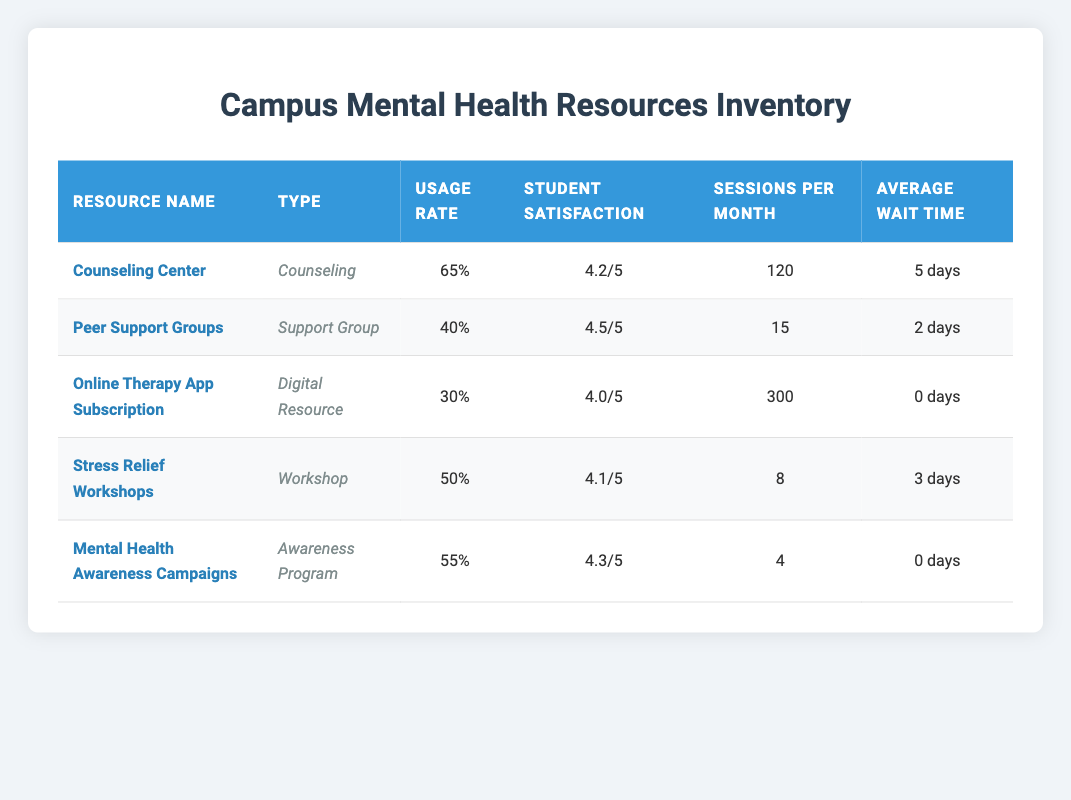What is the usage rate of the Counseling Center? The usage rate for the Counseling Center is directly listed in the table. It shows a percentage of 65.
Answer: 65 Which resource has the highest student satisfaction rating? By examining the Student Satisfaction Rating column, Peer Support Groups rated the highest at 4.5.
Answer: Peer Support Groups How many sessions per month are offered by the Online Therapy App Subscription? The table specifies that the Online Therapy App Subscription offers 300 sessions per month, which is directly stated.
Answer: 300 What is the average wait time across all resources? To find the average wait time, sum the average wait times (5 + 2 + 0 + 3 + 0 = 10) and divide by the number of resources (10/5 = 2).
Answer: 2 days Are there more sessions offered by the Counseling Center than the Peer Support Groups? The Counseling Center offers 120 sessions, and Peer Support Groups offer 15 sessions. Since 120 is greater than 15, the statement is true.
Answer: Yes What is the total usage rate percentage for all resources combined? Calculate the total usage rate percentage by adding all individual usage rates (65 + 40 + 30 + 50 + 55 = 240) and divide by the number of resources (240/5 = 48).
Answer: 48% Is the average wait time for the Online Therapy App Subscription less than the average wait time for Stress Relief Workshops? The average wait time for the Online Therapy App Subscription is 0 days and for Stress Relief Workshops it is 3 days. Since 0 is less than 3, the statement is true.
Answer: Yes What is the difference in usage rate percentages between Mental Health Awareness Campaigns and Peer Support Groups? The usage rate percentage for Mental Health Awareness Campaigns is 55, and for Peer Support Groups, it is 40. The difference is (55 - 40 = 15).
Answer: 15 Which type of resource has the lowest average wait time? Comparing the Average Wait Time column, the Online Therapy App Subscription and Mental Health Awareness Campaigns both have an average wait time of 0 days. Thus, they have the lowest wait time.
Answer: Online Therapy App Subscription and Mental Health Awareness Campaigns 